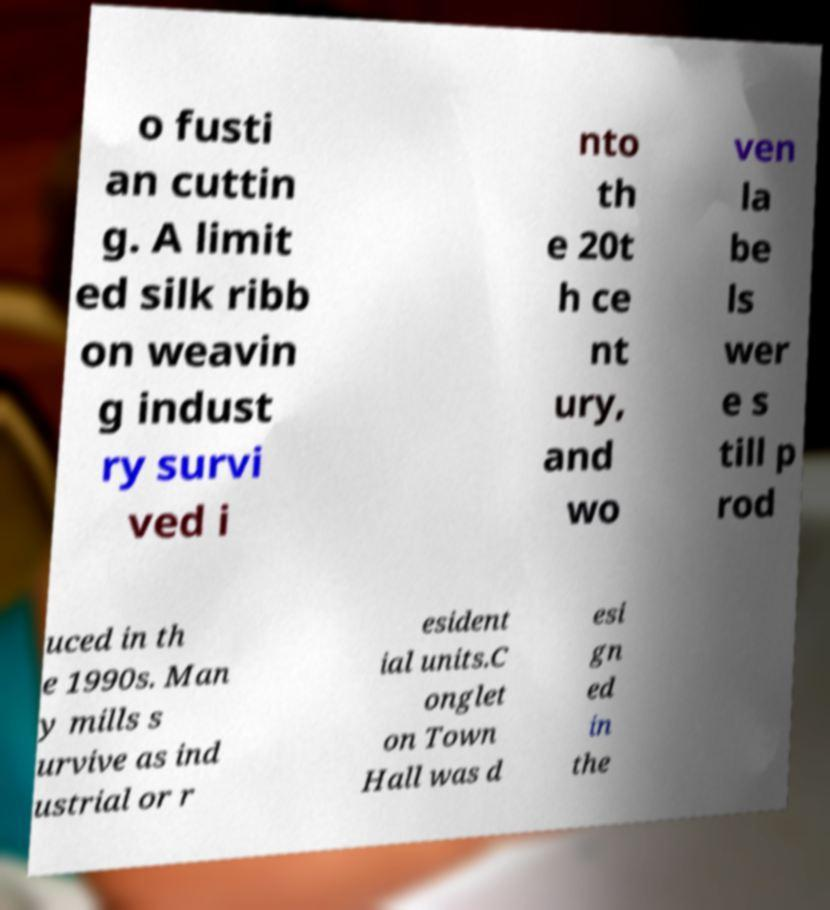There's text embedded in this image that I need extracted. Can you transcribe it verbatim? o fusti an cuttin g. A limit ed silk ribb on weavin g indust ry survi ved i nto th e 20t h ce nt ury, and wo ven la be ls wer e s till p rod uced in th e 1990s. Man y mills s urvive as ind ustrial or r esident ial units.C onglet on Town Hall was d esi gn ed in the 